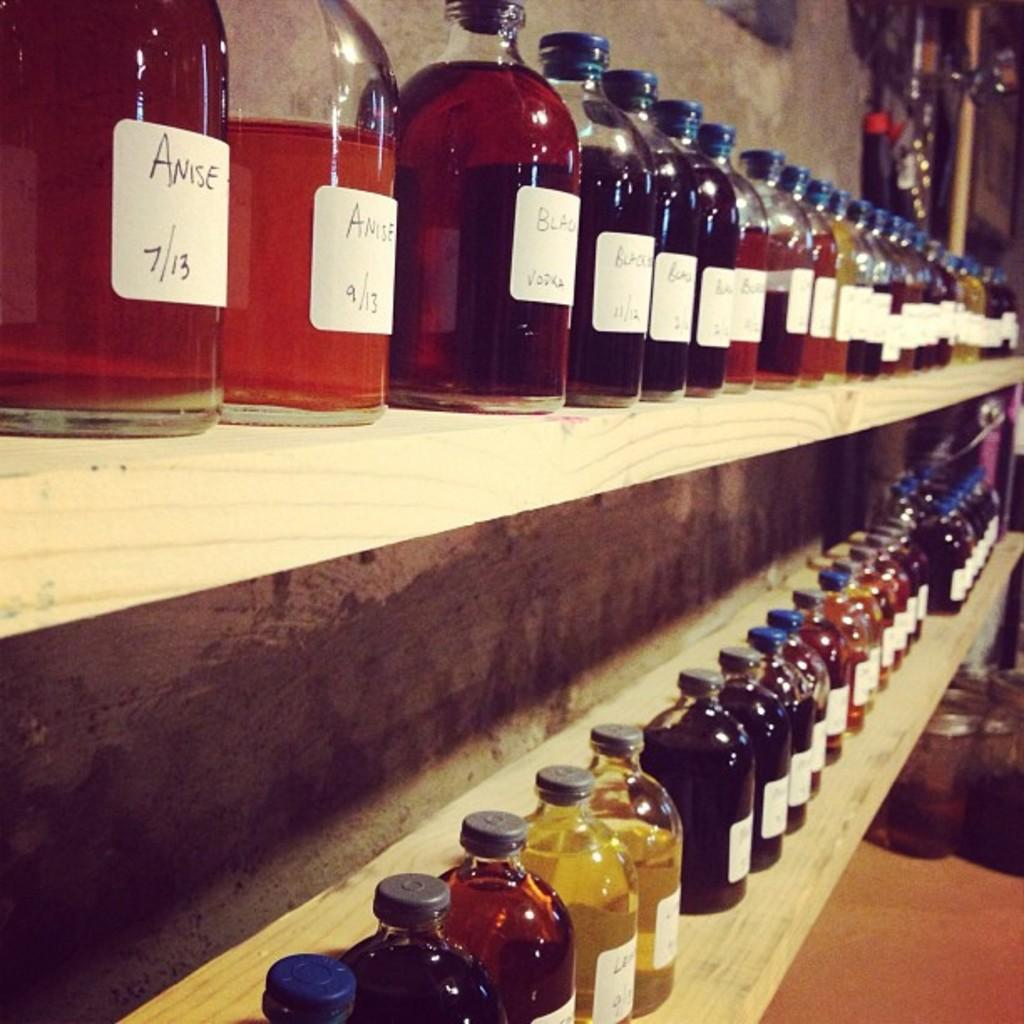<image>
Relay a brief, clear account of the picture shown. many bottles of flavors like Anise are on a shelf 